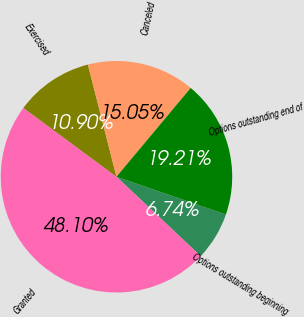Convert chart. <chart><loc_0><loc_0><loc_500><loc_500><pie_chart><fcel>Options outstanding beginning<fcel>Granted<fcel>Exercised<fcel>Canceled<fcel>Options outstanding end of<nl><fcel>6.74%<fcel>48.1%<fcel>10.9%<fcel>15.05%<fcel>19.21%<nl></chart> 